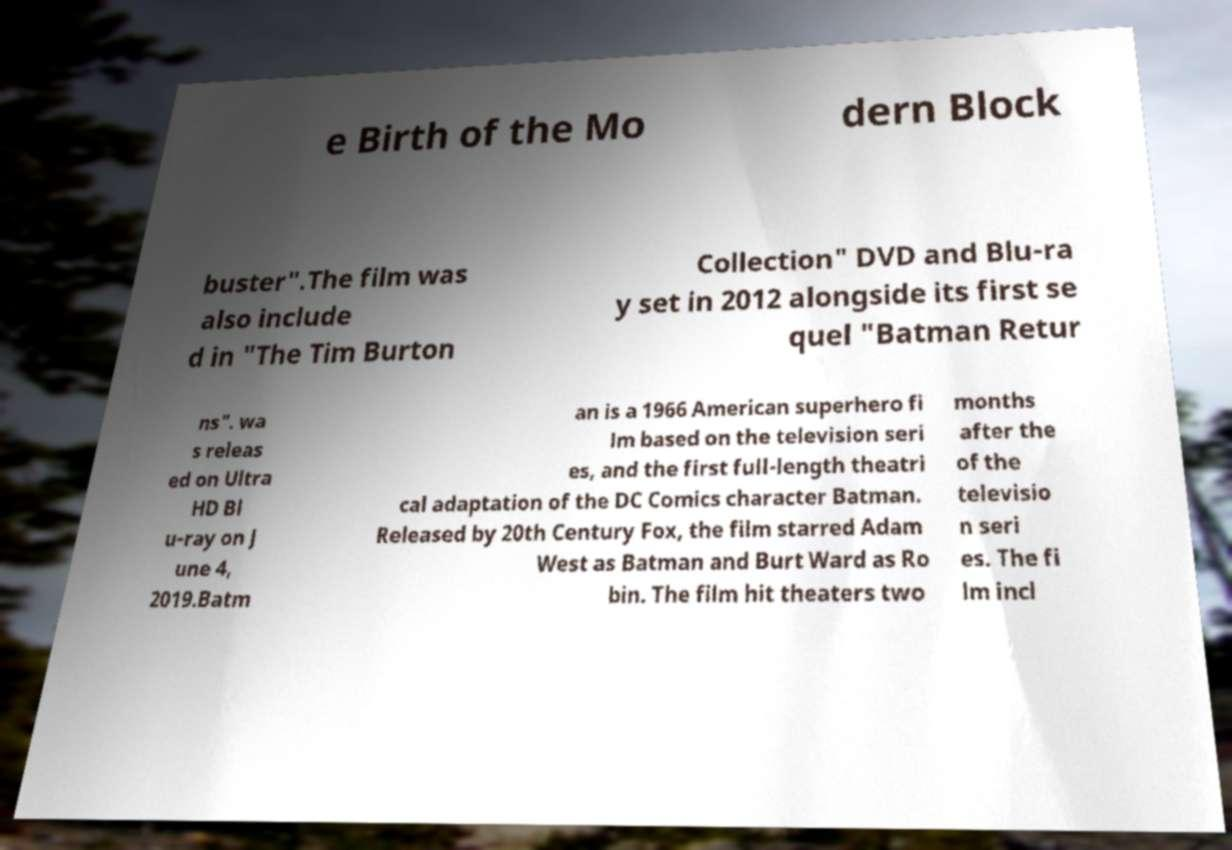I need the written content from this picture converted into text. Can you do that? e Birth of the Mo dern Block buster".The film was also include d in "The Tim Burton Collection" DVD and Blu-ra y set in 2012 alongside its first se quel "Batman Retur ns". wa s releas ed on Ultra HD Bl u-ray on J une 4, 2019.Batm an is a 1966 American superhero fi lm based on the television seri es, and the first full-length theatri cal adaptation of the DC Comics character Batman. Released by 20th Century Fox, the film starred Adam West as Batman and Burt Ward as Ro bin. The film hit theaters two months after the of the televisio n seri es. The fi lm incl 